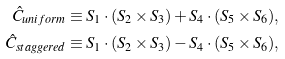Convert formula to latex. <formula><loc_0><loc_0><loc_500><loc_500>\hat { C } _ { u n i f o r m } & \equiv S _ { 1 } \cdot ( S _ { 2 } \times S _ { 3 } ) + S _ { 4 } \cdot ( S _ { 5 } \times S _ { 6 } ) , \\ \hat { C } _ { s t a g g e r e d } & \equiv S _ { 1 } \cdot ( S _ { 2 } \times S _ { 3 } ) - S _ { 4 } \cdot ( S _ { 5 } \times S _ { 6 } ) ,</formula> 